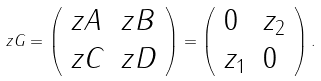<formula> <loc_0><loc_0><loc_500><loc_500>z G = \left ( \begin{array} { l l } z A & z B \\ z C & z D \end{array} \right ) = \left ( \begin{array} { l l } 0 & z _ { 2 } \\ z _ { 1 } & 0 \end{array} \right ) .</formula> 